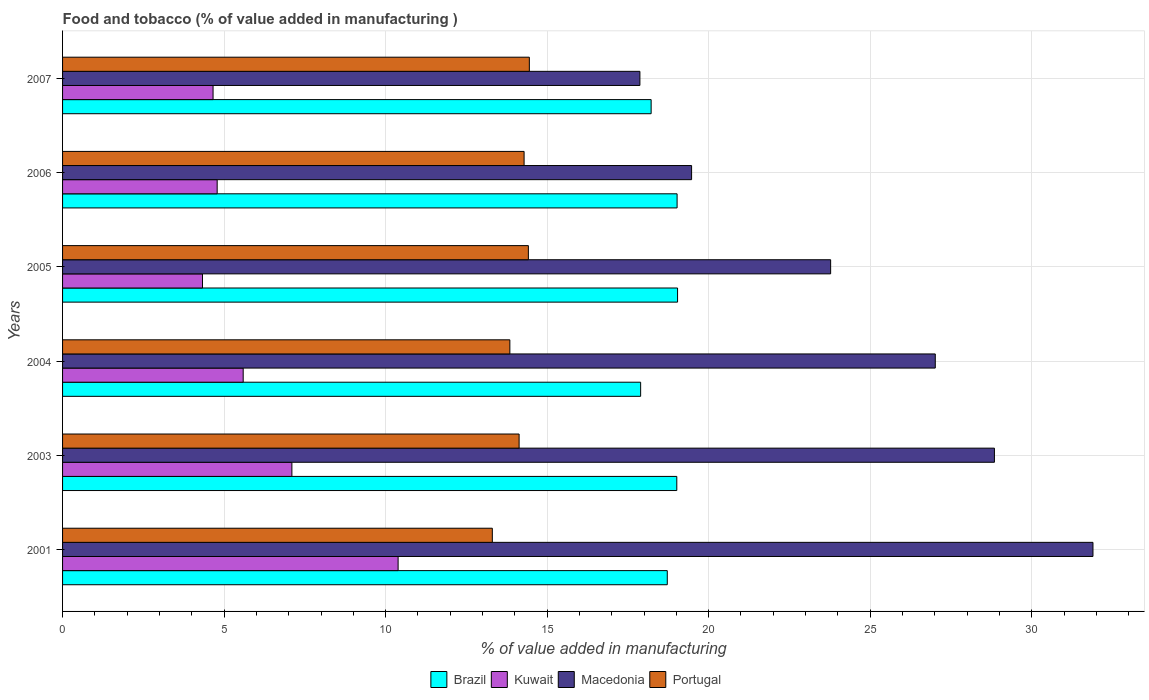Are the number of bars per tick equal to the number of legend labels?
Your answer should be very brief. Yes. What is the label of the 3rd group of bars from the top?
Give a very brief answer. 2005. In how many cases, is the number of bars for a given year not equal to the number of legend labels?
Offer a terse response. 0. What is the value added in manufacturing food and tobacco in Brazil in 2007?
Give a very brief answer. 18.22. Across all years, what is the maximum value added in manufacturing food and tobacco in Macedonia?
Make the answer very short. 31.9. Across all years, what is the minimum value added in manufacturing food and tobacco in Portugal?
Provide a short and direct response. 13.3. In which year was the value added in manufacturing food and tobacco in Brazil maximum?
Offer a terse response. 2005. In which year was the value added in manufacturing food and tobacco in Macedonia minimum?
Keep it short and to the point. 2007. What is the total value added in manufacturing food and tobacco in Kuwait in the graph?
Your answer should be compact. 36.85. What is the difference between the value added in manufacturing food and tobacco in Brazil in 2001 and that in 2007?
Your answer should be compact. 0.5. What is the difference between the value added in manufacturing food and tobacco in Brazil in 2005 and the value added in manufacturing food and tobacco in Macedonia in 2003?
Your answer should be very brief. -9.81. What is the average value added in manufacturing food and tobacco in Kuwait per year?
Provide a short and direct response. 6.14. In the year 2005, what is the difference between the value added in manufacturing food and tobacco in Portugal and value added in manufacturing food and tobacco in Brazil?
Your answer should be very brief. -4.62. What is the ratio of the value added in manufacturing food and tobacco in Kuwait in 2001 to that in 2004?
Give a very brief answer. 1.86. Is the value added in manufacturing food and tobacco in Portugal in 2001 less than that in 2003?
Offer a terse response. Yes. Is the difference between the value added in manufacturing food and tobacco in Portugal in 2001 and 2004 greater than the difference between the value added in manufacturing food and tobacco in Brazil in 2001 and 2004?
Your answer should be very brief. No. What is the difference between the highest and the second highest value added in manufacturing food and tobacco in Macedonia?
Offer a terse response. 3.05. What is the difference between the highest and the lowest value added in manufacturing food and tobacco in Portugal?
Keep it short and to the point. 1.15. In how many years, is the value added in manufacturing food and tobacco in Kuwait greater than the average value added in manufacturing food and tobacco in Kuwait taken over all years?
Your response must be concise. 2. What does the 1st bar from the bottom in 2007 represents?
Your response must be concise. Brazil. How many bars are there?
Make the answer very short. 24. Are the values on the major ticks of X-axis written in scientific E-notation?
Keep it short and to the point. No. Does the graph contain any zero values?
Your answer should be compact. No. Does the graph contain grids?
Offer a terse response. Yes. Where does the legend appear in the graph?
Make the answer very short. Bottom center. What is the title of the graph?
Your response must be concise. Food and tobacco (% of value added in manufacturing ). Does "Mozambique" appear as one of the legend labels in the graph?
Give a very brief answer. No. What is the label or title of the X-axis?
Your answer should be very brief. % of value added in manufacturing. What is the % of value added in manufacturing in Brazil in 2001?
Your response must be concise. 18.72. What is the % of value added in manufacturing in Kuwait in 2001?
Offer a terse response. 10.39. What is the % of value added in manufacturing in Macedonia in 2001?
Give a very brief answer. 31.9. What is the % of value added in manufacturing in Portugal in 2001?
Your answer should be very brief. 13.3. What is the % of value added in manufacturing of Brazil in 2003?
Ensure brevity in your answer.  19.01. What is the % of value added in manufacturing in Kuwait in 2003?
Offer a very short reply. 7.1. What is the % of value added in manufacturing of Macedonia in 2003?
Ensure brevity in your answer.  28.85. What is the % of value added in manufacturing in Portugal in 2003?
Provide a succinct answer. 14.13. What is the % of value added in manufacturing in Brazil in 2004?
Ensure brevity in your answer.  17.89. What is the % of value added in manufacturing of Kuwait in 2004?
Your response must be concise. 5.59. What is the % of value added in manufacturing in Macedonia in 2004?
Your response must be concise. 27.01. What is the % of value added in manufacturing in Portugal in 2004?
Provide a short and direct response. 13.85. What is the % of value added in manufacturing in Brazil in 2005?
Provide a succinct answer. 19.04. What is the % of value added in manufacturing in Kuwait in 2005?
Ensure brevity in your answer.  4.33. What is the % of value added in manufacturing of Macedonia in 2005?
Give a very brief answer. 23.78. What is the % of value added in manufacturing in Portugal in 2005?
Provide a short and direct response. 14.42. What is the % of value added in manufacturing of Brazil in 2006?
Offer a terse response. 19.02. What is the % of value added in manufacturing in Kuwait in 2006?
Provide a short and direct response. 4.79. What is the % of value added in manufacturing of Macedonia in 2006?
Provide a short and direct response. 19.47. What is the % of value added in manufacturing of Portugal in 2006?
Provide a short and direct response. 14.29. What is the % of value added in manufacturing in Brazil in 2007?
Offer a terse response. 18.22. What is the % of value added in manufacturing in Kuwait in 2007?
Offer a terse response. 4.66. What is the % of value added in manufacturing in Macedonia in 2007?
Make the answer very short. 17.87. What is the % of value added in manufacturing of Portugal in 2007?
Make the answer very short. 14.45. Across all years, what is the maximum % of value added in manufacturing in Brazil?
Offer a very short reply. 19.04. Across all years, what is the maximum % of value added in manufacturing of Kuwait?
Make the answer very short. 10.39. Across all years, what is the maximum % of value added in manufacturing of Macedonia?
Make the answer very short. 31.9. Across all years, what is the maximum % of value added in manufacturing in Portugal?
Your answer should be very brief. 14.45. Across all years, what is the minimum % of value added in manufacturing in Brazil?
Give a very brief answer. 17.89. Across all years, what is the minimum % of value added in manufacturing of Kuwait?
Make the answer very short. 4.33. Across all years, what is the minimum % of value added in manufacturing of Macedonia?
Offer a terse response. 17.87. Across all years, what is the minimum % of value added in manufacturing of Portugal?
Your answer should be compact. 13.3. What is the total % of value added in manufacturing in Brazil in the graph?
Offer a terse response. 111.91. What is the total % of value added in manufacturing of Kuwait in the graph?
Your answer should be compact. 36.85. What is the total % of value added in manufacturing of Macedonia in the graph?
Provide a short and direct response. 148.88. What is the total % of value added in manufacturing of Portugal in the graph?
Give a very brief answer. 84.44. What is the difference between the % of value added in manufacturing in Brazil in 2001 and that in 2003?
Make the answer very short. -0.29. What is the difference between the % of value added in manufacturing of Kuwait in 2001 and that in 2003?
Your answer should be very brief. 3.29. What is the difference between the % of value added in manufacturing in Macedonia in 2001 and that in 2003?
Make the answer very short. 3.05. What is the difference between the % of value added in manufacturing in Portugal in 2001 and that in 2003?
Ensure brevity in your answer.  -0.83. What is the difference between the % of value added in manufacturing in Brazil in 2001 and that in 2004?
Ensure brevity in your answer.  0.82. What is the difference between the % of value added in manufacturing in Kuwait in 2001 and that in 2004?
Provide a short and direct response. 4.8. What is the difference between the % of value added in manufacturing of Macedonia in 2001 and that in 2004?
Give a very brief answer. 4.88. What is the difference between the % of value added in manufacturing of Portugal in 2001 and that in 2004?
Offer a terse response. -0.54. What is the difference between the % of value added in manufacturing of Brazil in 2001 and that in 2005?
Ensure brevity in your answer.  -0.32. What is the difference between the % of value added in manufacturing of Kuwait in 2001 and that in 2005?
Offer a very short reply. 6.05. What is the difference between the % of value added in manufacturing of Macedonia in 2001 and that in 2005?
Your response must be concise. 8.12. What is the difference between the % of value added in manufacturing in Portugal in 2001 and that in 2005?
Make the answer very short. -1.12. What is the difference between the % of value added in manufacturing of Brazil in 2001 and that in 2006?
Provide a short and direct response. -0.3. What is the difference between the % of value added in manufacturing of Kuwait in 2001 and that in 2006?
Provide a succinct answer. 5.6. What is the difference between the % of value added in manufacturing of Macedonia in 2001 and that in 2006?
Ensure brevity in your answer.  12.42. What is the difference between the % of value added in manufacturing in Portugal in 2001 and that in 2006?
Give a very brief answer. -0.98. What is the difference between the % of value added in manufacturing of Brazil in 2001 and that in 2007?
Offer a terse response. 0.5. What is the difference between the % of value added in manufacturing in Kuwait in 2001 and that in 2007?
Make the answer very short. 5.73. What is the difference between the % of value added in manufacturing in Macedonia in 2001 and that in 2007?
Ensure brevity in your answer.  14.02. What is the difference between the % of value added in manufacturing of Portugal in 2001 and that in 2007?
Your answer should be very brief. -1.15. What is the difference between the % of value added in manufacturing of Brazil in 2003 and that in 2004?
Your answer should be compact. 1.12. What is the difference between the % of value added in manufacturing of Kuwait in 2003 and that in 2004?
Your answer should be compact. 1.51. What is the difference between the % of value added in manufacturing of Macedonia in 2003 and that in 2004?
Ensure brevity in your answer.  1.83. What is the difference between the % of value added in manufacturing of Portugal in 2003 and that in 2004?
Keep it short and to the point. 0.29. What is the difference between the % of value added in manufacturing of Brazil in 2003 and that in 2005?
Offer a very short reply. -0.02. What is the difference between the % of value added in manufacturing in Kuwait in 2003 and that in 2005?
Your answer should be compact. 2.77. What is the difference between the % of value added in manufacturing in Macedonia in 2003 and that in 2005?
Make the answer very short. 5.07. What is the difference between the % of value added in manufacturing in Portugal in 2003 and that in 2005?
Give a very brief answer. -0.29. What is the difference between the % of value added in manufacturing of Brazil in 2003 and that in 2006?
Offer a terse response. -0.01. What is the difference between the % of value added in manufacturing in Kuwait in 2003 and that in 2006?
Offer a terse response. 2.31. What is the difference between the % of value added in manufacturing of Macedonia in 2003 and that in 2006?
Make the answer very short. 9.37. What is the difference between the % of value added in manufacturing of Portugal in 2003 and that in 2006?
Offer a terse response. -0.15. What is the difference between the % of value added in manufacturing in Brazil in 2003 and that in 2007?
Your answer should be compact. 0.79. What is the difference between the % of value added in manufacturing of Kuwait in 2003 and that in 2007?
Offer a terse response. 2.44. What is the difference between the % of value added in manufacturing of Macedonia in 2003 and that in 2007?
Keep it short and to the point. 10.97. What is the difference between the % of value added in manufacturing of Portugal in 2003 and that in 2007?
Ensure brevity in your answer.  -0.32. What is the difference between the % of value added in manufacturing in Brazil in 2004 and that in 2005?
Keep it short and to the point. -1.14. What is the difference between the % of value added in manufacturing in Kuwait in 2004 and that in 2005?
Ensure brevity in your answer.  1.26. What is the difference between the % of value added in manufacturing in Macedonia in 2004 and that in 2005?
Offer a terse response. 3.24. What is the difference between the % of value added in manufacturing of Portugal in 2004 and that in 2005?
Give a very brief answer. -0.57. What is the difference between the % of value added in manufacturing of Brazil in 2004 and that in 2006?
Your answer should be compact. -1.13. What is the difference between the % of value added in manufacturing in Kuwait in 2004 and that in 2006?
Make the answer very short. 0.81. What is the difference between the % of value added in manufacturing of Macedonia in 2004 and that in 2006?
Provide a succinct answer. 7.54. What is the difference between the % of value added in manufacturing of Portugal in 2004 and that in 2006?
Your answer should be very brief. -0.44. What is the difference between the % of value added in manufacturing of Brazil in 2004 and that in 2007?
Provide a succinct answer. -0.33. What is the difference between the % of value added in manufacturing in Kuwait in 2004 and that in 2007?
Make the answer very short. 0.93. What is the difference between the % of value added in manufacturing of Macedonia in 2004 and that in 2007?
Provide a short and direct response. 9.14. What is the difference between the % of value added in manufacturing in Portugal in 2004 and that in 2007?
Your answer should be very brief. -0.6. What is the difference between the % of value added in manufacturing in Brazil in 2005 and that in 2006?
Offer a very short reply. 0.01. What is the difference between the % of value added in manufacturing in Kuwait in 2005 and that in 2006?
Your response must be concise. -0.45. What is the difference between the % of value added in manufacturing of Macedonia in 2005 and that in 2006?
Give a very brief answer. 4.3. What is the difference between the % of value added in manufacturing in Portugal in 2005 and that in 2006?
Your response must be concise. 0.13. What is the difference between the % of value added in manufacturing in Brazil in 2005 and that in 2007?
Your answer should be very brief. 0.82. What is the difference between the % of value added in manufacturing of Kuwait in 2005 and that in 2007?
Provide a short and direct response. -0.33. What is the difference between the % of value added in manufacturing of Macedonia in 2005 and that in 2007?
Provide a succinct answer. 5.9. What is the difference between the % of value added in manufacturing in Portugal in 2005 and that in 2007?
Your response must be concise. -0.03. What is the difference between the % of value added in manufacturing in Brazil in 2006 and that in 2007?
Your answer should be compact. 0.8. What is the difference between the % of value added in manufacturing of Kuwait in 2006 and that in 2007?
Make the answer very short. 0.13. What is the difference between the % of value added in manufacturing of Macedonia in 2006 and that in 2007?
Offer a terse response. 1.6. What is the difference between the % of value added in manufacturing in Portugal in 2006 and that in 2007?
Ensure brevity in your answer.  -0.16. What is the difference between the % of value added in manufacturing of Brazil in 2001 and the % of value added in manufacturing of Kuwait in 2003?
Provide a succinct answer. 11.62. What is the difference between the % of value added in manufacturing of Brazil in 2001 and the % of value added in manufacturing of Macedonia in 2003?
Provide a succinct answer. -10.13. What is the difference between the % of value added in manufacturing in Brazil in 2001 and the % of value added in manufacturing in Portugal in 2003?
Provide a succinct answer. 4.59. What is the difference between the % of value added in manufacturing in Kuwait in 2001 and the % of value added in manufacturing in Macedonia in 2003?
Keep it short and to the point. -18.46. What is the difference between the % of value added in manufacturing of Kuwait in 2001 and the % of value added in manufacturing of Portugal in 2003?
Make the answer very short. -3.75. What is the difference between the % of value added in manufacturing of Macedonia in 2001 and the % of value added in manufacturing of Portugal in 2003?
Your response must be concise. 17.76. What is the difference between the % of value added in manufacturing of Brazil in 2001 and the % of value added in manufacturing of Kuwait in 2004?
Ensure brevity in your answer.  13.13. What is the difference between the % of value added in manufacturing in Brazil in 2001 and the % of value added in manufacturing in Macedonia in 2004?
Your answer should be very brief. -8.3. What is the difference between the % of value added in manufacturing of Brazil in 2001 and the % of value added in manufacturing of Portugal in 2004?
Keep it short and to the point. 4.87. What is the difference between the % of value added in manufacturing of Kuwait in 2001 and the % of value added in manufacturing of Macedonia in 2004?
Your response must be concise. -16.63. What is the difference between the % of value added in manufacturing of Kuwait in 2001 and the % of value added in manufacturing of Portugal in 2004?
Provide a short and direct response. -3.46. What is the difference between the % of value added in manufacturing of Macedonia in 2001 and the % of value added in manufacturing of Portugal in 2004?
Provide a succinct answer. 18.05. What is the difference between the % of value added in manufacturing of Brazil in 2001 and the % of value added in manufacturing of Kuwait in 2005?
Offer a terse response. 14.39. What is the difference between the % of value added in manufacturing in Brazil in 2001 and the % of value added in manufacturing in Macedonia in 2005?
Provide a short and direct response. -5.06. What is the difference between the % of value added in manufacturing of Brazil in 2001 and the % of value added in manufacturing of Portugal in 2005?
Your answer should be compact. 4.3. What is the difference between the % of value added in manufacturing of Kuwait in 2001 and the % of value added in manufacturing of Macedonia in 2005?
Offer a very short reply. -13.39. What is the difference between the % of value added in manufacturing of Kuwait in 2001 and the % of value added in manufacturing of Portugal in 2005?
Your answer should be compact. -4.03. What is the difference between the % of value added in manufacturing of Macedonia in 2001 and the % of value added in manufacturing of Portugal in 2005?
Offer a terse response. 17.48. What is the difference between the % of value added in manufacturing in Brazil in 2001 and the % of value added in manufacturing in Kuwait in 2006?
Your response must be concise. 13.93. What is the difference between the % of value added in manufacturing in Brazil in 2001 and the % of value added in manufacturing in Macedonia in 2006?
Offer a terse response. -0.75. What is the difference between the % of value added in manufacturing of Brazil in 2001 and the % of value added in manufacturing of Portugal in 2006?
Provide a short and direct response. 4.43. What is the difference between the % of value added in manufacturing in Kuwait in 2001 and the % of value added in manufacturing in Macedonia in 2006?
Provide a succinct answer. -9.08. What is the difference between the % of value added in manufacturing in Kuwait in 2001 and the % of value added in manufacturing in Portugal in 2006?
Provide a short and direct response. -3.9. What is the difference between the % of value added in manufacturing of Macedonia in 2001 and the % of value added in manufacturing of Portugal in 2006?
Your answer should be compact. 17.61. What is the difference between the % of value added in manufacturing of Brazil in 2001 and the % of value added in manufacturing of Kuwait in 2007?
Your answer should be very brief. 14.06. What is the difference between the % of value added in manufacturing in Brazil in 2001 and the % of value added in manufacturing in Macedonia in 2007?
Offer a very short reply. 0.85. What is the difference between the % of value added in manufacturing in Brazil in 2001 and the % of value added in manufacturing in Portugal in 2007?
Provide a succinct answer. 4.27. What is the difference between the % of value added in manufacturing in Kuwait in 2001 and the % of value added in manufacturing in Macedonia in 2007?
Your response must be concise. -7.48. What is the difference between the % of value added in manufacturing of Kuwait in 2001 and the % of value added in manufacturing of Portugal in 2007?
Your response must be concise. -4.06. What is the difference between the % of value added in manufacturing in Macedonia in 2001 and the % of value added in manufacturing in Portugal in 2007?
Your answer should be compact. 17.45. What is the difference between the % of value added in manufacturing in Brazil in 2003 and the % of value added in manufacturing in Kuwait in 2004?
Ensure brevity in your answer.  13.42. What is the difference between the % of value added in manufacturing of Brazil in 2003 and the % of value added in manufacturing of Macedonia in 2004?
Offer a very short reply. -8. What is the difference between the % of value added in manufacturing in Brazil in 2003 and the % of value added in manufacturing in Portugal in 2004?
Give a very brief answer. 5.17. What is the difference between the % of value added in manufacturing of Kuwait in 2003 and the % of value added in manufacturing of Macedonia in 2004?
Make the answer very short. -19.92. What is the difference between the % of value added in manufacturing of Kuwait in 2003 and the % of value added in manufacturing of Portugal in 2004?
Provide a succinct answer. -6.75. What is the difference between the % of value added in manufacturing in Macedonia in 2003 and the % of value added in manufacturing in Portugal in 2004?
Your answer should be compact. 15. What is the difference between the % of value added in manufacturing of Brazil in 2003 and the % of value added in manufacturing of Kuwait in 2005?
Make the answer very short. 14.68. What is the difference between the % of value added in manufacturing of Brazil in 2003 and the % of value added in manufacturing of Macedonia in 2005?
Your answer should be very brief. -4.76. What is the difference between the % of value added in manufacturing of Brazil in 2003 and the % of value added in manufacturing of Portugal in 2005?
Your response must be concise. 4.59. What is the difference between the % of value added in manufacturing of Kuwait in 2003 and the % of value added in manufacturing of Macedonia in 2005?
Your answer should be compact. -16.68. What is the difference between the % of value added in manufacturing in Kuwait in 2003 and the % of value added in manufacturing in Portugal in 2005?
Make the answer very short. -7.32. What is the difference between the % of value added in manufacturing in Macedonia in 2003 and the % of value added in manufacturing in Portugal in 2005?
Provide a succinct answer. 14.43. What is the difference between the % of value added in manufacturing of Brazil in 2003 and the % of value added in manufacturing of Kuwait in 2006?
Your answer should be very brief. 14.23. What is the difference between the % of value added in manufacturing of Brazil in 2003 and the % of value added in manufacturing of Macedonia in 2006?
Give a very brief answer. -0.46. What is the difference between the % of value added in manufacturing in Brazil in 2003 and the % of value added in manufacturing in Portugal in 2006?
Offer a very short reply. 4.73. What is the difference between the % of value added in manufacturing in Kuwait in 2003 and the % of value added in manufacturing in Macedonia in 2006?
Offer a terse response. -12.37. What is the difference between the % of value added in manufacturing in Kuwait in 2003 and the % of value added in manufacturing in Portugal in 2006?
Provide a short and direct response. -7.19. What is the difference between the % of value added in manufacturing of Macedonia in 2003 and the % of value added in manufacturing of Portugal in 2006?
Give a very brief answer. 14.56. What is the difference between the % of value added in manufacturing of Brazil in 2003 and the % of value added in manufacturing of Kuwait in 2007?
Your answer should be compact. 14.35. What is the difference between the % of value added in manufacturing in Brazil in 2003 and the % of value added in manufacturing in Macedonia in 2007?
Keep it short and to the point. 1.14. What is the difference between the % of value added in manufacturing in Brazil in 2003 and the % of value added in manufacturing in Portugal in 2007?
Offer a terse response. 4.56. What is the difference between the % of value added in manufacturing in Kuwait in 2003 and the % of value added in manufacturing in Macedonia in 2007?
Your answer should be compact. -10.77. What is the difference between the % of value added in manufacturing of Kuwait in 2003 and the % of value added in manufacturing of Portugal in 2007?
Make the answer very short. -7.35. What is the difference between the % of value added in manufacturing in Macedonia in 2003 and the % of value added in manufacturing in Portugal in 2007?
Your answer should be very brief. 14.4. What is the difference between the % of value added in manufacturing in Brazil in 2004 and the % of value added in manufacturing in Kuwait in 2005?
Make the answer very short. 13.56. What is the difference between the % of value added in manufacturing of Brazil in 2004 and the % of value added in manufacturing of Macedonia in 2005?
Make the answer very short. -5.88. What is the difference between the % of value added in manufacturing in Brazil in 2004 and the % of value added in manufacturing in Portugal in 2005?
Provide a short and direct response. 3.48. What is the difference between the % of value added in manufacturing in Kuwait in 2004 and the % of value added in manufacturing in Macedonia in 2005?
Give a very brief answer. -18.18. What is the difference between the % of value added in manufacturing in Kuwait in 2004 and the % of value added in manufacturing in Portugal in 2005?
Provide a succinct answer. -8.83. What is the difference between the % of value added in manufacturing in Macedonia in 2004 and the % of value added in manufacturing in Portugal in 2005?
Provide a short and direct response. 12.6. What is the difference between the % of value added in manufacturing of Brazil in 2004 and the % of value added in manufacturing of Kuwait in 2006?
Provide a succinct answer. 13.11. What is the difference between the % of value added in manufacturing in Brazil in 2004 and the % of value added in manufacturing in Macedonia in 2006?
Make the answer very short. -1.58. What is the difference between the % of value added in manufacturing of Brazil in 2004 and the % of value added in manufacturing of Portugal in 2006?
Offer a very short reply. 3.61. What is the difference between the % of value added in manufacturing of Kuwait in 2004 and the % of value added in manufacturing of Macedonia in 2006?
Make the answer very short. -13.88. What is the difference between the % of value added in manufacturing in Kuwait in 2004 and the % of value added in manufacturing in Portugal in 2006?
Offer a terse response. -8.7. What is the difference between the % of value added in manufacturing of Macedonia in 2004 and the % of value added in manufacturing of Portugal in 2006?
Your response must be concise. 12.73. What is the difference between the % of value added in manufacturing of Brazil in 2004 and the % of value added in manufacturing of Kuwait in 2007?
Keep it short and to the point. 13.24. What is the difference between the % of value added in manufacturing in Brazil in 2004 and the % of value added in manufacturing in Macedonia in 2007?
Offer a very short reply. 0.02. What is the difference between the % of value added in manufacturing of Brazil in 2004 and the % of value added in manufacturing of Portugal in 2007?
Your answer should be very brief. 3.45. What is the difference between the % of value added in manufacturing of Kuwait in 2004 and the % of value added in manufacturing of Macedonia in 2007?
Your answer should be compact. -12.28. What is the difference between the % of value added in manufacturing of Kuwait in 2004 and the % of value added in manufacturing of Portugal in 2007?
Give a very brief answer. -8.86. What is the difference between the % of value added in manufacturing in Macedonia in 2004 and the % of value added in manufacturing in Portugal in 2007?
Your answer should be compact. 12.57. What is the difference between the % of value added in manufacturing of Brazil in 2005 and the % of value added in manufacturing of Kuwait in 2006?
Give a very brief answer. 14.25. What is the difference between the % of value added in manufacturing of Brazil in 2005 and the % of value added in manufacturing of Macedonia in 2006?
Provide a succinct answer. -0.43. What is the difference between the % of value added in manufacturing of Brazil in 2005 and the % of value added in manufacturing of Portugal in 2006?
Make the answer very short. 4.75. What is the difference between the % of value added in manufacturing in Kuwait in 2005 and the % of value added in manufacturing in Macedonia in 2006?
Your response must be concise. -15.14. What is the difference between the % of value added in manufacturing in Kuwait in 2005 and the % of value added in manufacturing in Portugal in 2006?
Offer a very short reply. -9.95. What is the difference between the % of value added in manufacturing in Macedonia in 2005 and the % of value added in manufacturing in Portugal in 2006?
Give a very brief answer. 9.49. What is the difference between the % of value added in manufacturing in Brazil in 2005 and the % of value added in manufacturing in Kuwait in 2007?
Your response must be concise. 14.38. What is the difference between the % of value added in manufacturing of Brazil in 2005 and the % of value added in manufacturing of Macedonia in 2007?
Provide a short and direct response. 1.17. What is the difference between the % of value added in manufacturing of Brazil in 2005 and the % of value added in manufacturing of Portugal in 2007?
Offer a terse response. 4.59. What is the difference between the % of value added in manufacturing of Kuwait in 2005 and the % of value added in manufacturing of Macedonia in 2007?
Offer a very short reply. -13.54. What is the difference between the % of value added in manufacturing of Kuwait in 2005 and the % of value added in manufacturing of Portugal in 2007?
Your answer should be compact. -10.12. What is the difference between the % of value added in manufacturing of Macedonia in 2005 and the % of value added in manufacturing of Portugal in 2007?
Give a very brief answer. 9.33. What is the difference between the % of value added in manufacturing in Brazil in 2006 and the % of value added in manufacturing in Kuwait in 2007?
Provide a short and direct response. 14.36. What is the difference between the % of value added in manufacturing of Brazil in 2006 and the % of value added in manufacturing of Macedonia in 2007?
Your answer should be compact. 1.15. What is the difference between the % of value added in manufacturing of Brazil in 2006 and the % of value added in manufacturing of Portugal in 2007?
Your answer should be compact. 4.57. What is the difference between the % of value added in manufacturing of Kuwait in 2006 and the % of value added in manufacturing of Macedonia in 2007?
Provide a short and direct response. -13.09. What is the difference between the % of value added in manufacturing of Kuwait in 2006 and the % of value added in manufacturing of Portugal in 2007?
Keep it short and to the point. -9.66. What is the difference between the % of value added in manufacturing of Macedonia in 2006 and the % of value added in manufacturing of Portugal in 2007?
Your response must be concise. 5.02. What is the average % of value added in manufacturing in Brazil per year?
Ensure brevity in your answer.  18.65. What is the average % of value added in manufacturing in Kuwait per year?
Offer a very short reply. 6.14. What is the average % of value added in manufacturing in Macedonia per year?
Make the answer very short. 24.81. What is the average % of value added in manufacturing of Portugal per year?
Provide a succinct answer. 14.07. In the year 2001, what is the difference between the % of value added in manufacturing in Brazil and % of value added in manufacturing in Kuwait?
Offer a very short reply. 8.33. In the year 2001, what is the difference between the % of value added in manufacturing in Brazil and % of value added in manufacturing in Macedonia?
Your response must be concise. -13.18. In the year 2001, what is the difference between the % of value added in manufacturing in Brazil and % of value added in manufacturing in Portugal?
Ensure brevity in your answer.  5.42. In the year 2001, what is the difference between the % of value added in manufacturing of Kuwait and % of value added in manufacturing of Macedonia?
Offer a terse response. -21.51. In the year 2001, what is the difference between the % of value added in manufacturing in Kuwait and % of value added in manufacturing in Portugal?
Offer a terse response. -2.92. In the year 2001, what is the difference between the % of value added in manufacturing of Macedonia and % of value added in manufacturing of Portugal?
Offer a terse response. 18.59. In the year 2003, what is the difference between the % of value added in manufacturing of Brazil and % of value added in manufacturing of Kuwait?
Offer a very short reply. 11.91. In the year 2003, what is the difference between the % of value added in manufacturing of Brazil and % of value added in manufacturing of Macedonia?
Provide a short and direct response. -9.83. In the year 2003, what is the difference between the % of value added in manufacturing in Brazil and % of value added in manufacturing in Portugal?
Provide a succinct answer. 4.88. In the year 2003, what is the difference between the % of value added in manufacturing of Kuwait and % of value added in manufacturing of Macedonia?
Your response must be concise. -21.75. In the year 2003, what is the difference between the % of value added in manufacturing in Kuwait and % of value added in manufacturing in Portugal?
Offer a terse response. -7.03. In the year 2003, what is the difference between the % of value added in manufacturing in Macedonia and % of value added in manufacturing in Portugal?
Your answer should be very brief. 14.71. In the year 2004, what is the difference between the % of value added in manufacturing in Brazil and % of value added in manufacturing in Kuwait?
Make the answer very short. 12.3. In the year 2004, what is the difference between the % of value added in manufacturing of Brazil and % of value added in manufacturing of Macedonia?
Give a very brief answer. -9.12. In the year 2004, what is the difference between the % of value added in manufacturing in Brazil and % of value added in manufacturing in Portugal?
Your answer should be very brief. 4.05. In the year 2004, what is the difference between the % of value added in manufacturing of Kuwait and % of value added in manufacturing of Macedonia?
Provide a short and direct response. -21.42. In the year 2004, what is the difference between the % of value added in manufacturing in Kuwait and % of value added in manufacturing in Portugal?
Offer a very short reply. -8.25. In the year 2004, what is the difference between the % of value added in manufacturing of Macedonia and % of value added in manufacturing of Portugal?
Offer a terse response. 13.17. In the year 2005, what is the difference between the % of value added in manufacturing of Brazil and % of value added in manufacturing of Kuwait?
Your answer should be very brief. 14.71. In the year 2005, what is the difference between the % of value added in manufacturing of Brazil and % of value added in manufacturing of Macedonia?
Your answer should be compact. -4.74. In the year 2005, what is the difference between the % of value added in manufacturing in Brazil and % of value added in manufacturing in Portugal?
Offer a terse response. 4.62. In the year 2005, what is the difference between the % of value added in manufacturing of Kuwait and % of value added in manufacturing of Macedonia?
Your answer should be very brief. -19.44. In the year 2005, what is the difference between the % of value added in manufacturing in Kuwait and % of value added in manufacturing in Portugal?
Your answer should be compact. -10.09. In the year 2005, what is the difference between the % of value added in manufacturing in Macedonia and % of value added in manufacturing in Portugal?
Offer a terse response. 9.36. In the year 2006, what is the difference between the % of value added in manufacturing of Brazil and % of value added in manufacturing of Kuwait?
Offer a terse response. 14.24. In the year 2006, what is the difference between the % of value added in manufacturing of Brazil and % of value added in manufacturing of Macedonia?
Provide a short and direct response. -0.45. In the year 2006, what is the difference between the % of value added in manufacturing of Brazil and % of value added in manufacturing of Portugal?
Offer a terse response. 4.74. In the year 2006, what is the difference between the % of value added in manufacturing of Kuwait and % of value added in manufacturing of Macedonia?
Your answer should be compact. -14.69. In the year 2006, what is the difference between the % of value added in manufacturing in Kuwait and % of value added in manufacturing in Portugal?
Offer a terse response. -9.5. In the year 2006, what is the difference between the % of value added in manufacturing of Macedonia and % of value added in manufacturing of Portugal?
Your answer should be very brief. 5.18. In the year 2007, what is the difference between the % of value added in manufacturing in Brazil and % of value added in manufacturing in Kuwait?
Offer a terse response. 13.56. In the year 2007, what is the difference between the % of value added in manufacturing in Brazil and % of value added in manufacturing in Macedonia?
Provide a short and direct response. 0.35. In the year 2007, what is the difference between the % of value added in manufacturing of Brazil and % of value added in manufacturing of Portugal?
Offer a very short reply. 3.77. In the year 2007, what is the difference between the % of value added in manufacturing of Kuwait and % of value added in manufacturing of Macedonia?
Ensure brevity in your answer.  -13.21. In the year 2007, what is the difference between the % of value added in manufacturing in Kuwait and % of value added in manufacturing in Portugal?
Give a very brief answer. -9.79. In the year 2007, what is the difference between the % of value added in manufacturing in Macedonia and % of value added in manufacturing in Portugal?
Your response must be concise. 3.42. What is the ratio of the % of value added in manufacturing of Brazil in 2001 to that in 2003?
Give a very brief answer. 0.98. What is the ratio of the % of value added in manufacturing in Kuwait in 2001 to that in 2003?
Provide a short and direct response. 1.46. What is the ratio of the % of value added in manufacturing in Macedonia in 2001 to that in 2003?
Offer a terse response. 1.11. What is the ratio of the % of value added in manufacturing in Portugal in 2001 to that in 2003?
Offer a very short reply. 0.94. What is the ratio of the % of value added in manufacturing in Brazil in 2001 to that in 2004?
Give a very brief answer. 1.05. What is the ratio of the % of value added in manufacturing of Kuwait in 2001 to that in 2004?
Your answer should be compact. 1.86. What is the ratio of the % of value added in manufacturing in Macedonia in 2001 to that in 2004?
Give a very brief answer. 1.18. What is the ratio of the % of value added in manufacturing in Portugal in 2001 to that in 2004?
Make the answer very short. 0.96. What is the ratio of the % of value added in manufacturing in Brazil in 2001 to that in 2005?
Offer a terse response. 0.98. What is the ratio of the % of value added in manufacturing in Kuwait in 2001 to that in 2005?
Make the answer very short. 2.4. What is the ratio of the % of value added in manufacturing in Macedonia in 2001 to that in 2005?
Give a very brief answer. 1.34. What is the ratio of the % of value added in manufacturing in Portugal in 2001 to that in 2005?
Your response must be concise. 0.92. What is the ratio of the % of value added in manufacturing of Kuwait in 2001 to that in 2006?
Offer a terse response. 2.17. What is the ratio of the % of value added in manufacturing of Macedonia in 2001 to that in 2006?
Provide a succinct answer. 1.64. What is the ratio of the % of value added in manufacturing in Portugal in 2001 to that in 2006?
Keep it short and to the point. 0.93. What is the ratio of the % of value added in manufacturing in Brazil in 2001 to that in 2007?
Provide a succinct answer. 1.03. What is the ratio of the % of value added in manufacturing in Kuwait in 2001 to that in 2007?
Offer a terse response. 2.23. What is the ratio of the % of value added in manufacturing of Macedonia in 2001 to that in 2007?
Your response must be concise. 1.78. What is the ratio of the % of value added in manufacturing of Portugal in 2001 to that in 2007?
Make the answer very short. 0.92. What is the ratio of the % of value added in manufacturing in Brazil in 2003 to that in 2004?
Your answer should be compact. 1.06. What is the ratio of the % of value added in manufacturing of Kuwait in 2003 to that in 2004?
Offer a very short reply. 1.27. What is the ratio of the % of value added in manufacturing of Macedonia in 2003 to that in 2004?
Provide a short and direct response. 1.07. What is the ratio of the % of value added in manufacturing of Portugal in 2003 to that in 2004?
Offer a very short reply. 1.02. What is the ratio of the % of value added in manufacturing of Brazil in 2003 to that in 2005?
Provide a short and direct response. 1. What is the ratio of the % of value added in manufacturing in Kuwait in 2003 to that in 2005?
Provide a short and direct response. 1.64. What is the ratio of the % of value added in manufacturing in Macedonia in 2003 to that in 2005?
Offer a terse response. 1.21. What is the ratio of the % of value added in manufacturing of Portugal in 2003 to that in 2005?
Give a very brief answer. 0.98. What is the ratio of the % of value added in manufacturing in Brazil in 2003 to that in 2006?
Your response must be concise. 1. What is the ratio of the % of value added in manufacturing in Kuwait in 2003 to that in 2006?
Offer a terse response. 1.48. What is the ratio of the % of value added in manufacturing in Macedonia in 2003 to that in 2006?
Offer a very short reply. 1.48. What is the ratio of the % of value added in manufacturing in Portugal in 2003 to that in 2006?
Provide a succinct answer. 0.99. What is the ratio of the % of value added in manufacturing in Brazil in 2003 to that in 2007?
Provide a short and direct response. 1.04. What is the ratio of the % of value added in manufacturing of Kuwait in 2003 to that in 2007?
Your answer should be compact. 1.52. What is the ratio of the % of value added in manufacturing in Macedonia in 2003 to that in 2007?
Your response must be concise. 1.61. What is the ratio of the % of value added in manufacturing of Portugal in 2003 to that in 2007?
Provide a short and direct response. 0.98. What is the ratio of the % of value added in manufacturing in Brazil in 2004 to that in 2005?
Offer a terse response. 0.94. What is the ratio of the % of value added in manufacturing of Kuwait in 2004 to that in 2005?
Offer a terse response. 1.29. What is the ratio of the % of value added in manufacturing in Macedonia in 2004 to that in 2005?
Offer a very short reply. 1.14. What is the ratio of the % of value added in manufacturing of Portugal in 2004 to that in 2005?
Make the answer very short. 0.96. What is the ratio of the % of value added in manufacturing in Brazil in 2004 to that in 2006?
Provide a short and direct response. 0.94. What is the ratio of the % of value added in manufacturing of Kuwait in 2004 to that in 2006?
Offer a terse response. 1.17. What is the ratio of the % of value added in manufacturing in Macedonia in 2004 to that in 2006?
Your answer should be very brief. 1.39. What is the ratio of the % of value added in manufacturing of Portugal in 2004 to that in 2006?
Your response must be concise. 0.97. What is the ratio of the % of value added in manufacturing of Brazil in 2004 to that in 2007?
Provide a short and direct response. 0.98. What is the ratio of the % of value added in manufacturing of Kuwait in 2004 to that in 2007?
Your answer should be compact. 1.2. What is the ratio of the % of value added in manufacturing of Macedonia in 2004 to that in 2007?
Provide a short and direct response. 1.51. What is the ratio of the % of value added in manufacturing in Brazil in 2005 to that in 2006?
Keep it short and to the point. 1. What is the ratio of the % of value added in manufacturing in Kuwait in 2005 to that in 2006?
Keep it short and to the point. 0.91. What is the ratio of the % of value added in manufacturing of Macedonia in 2005 to that in 2006?
Offer a very short reply. 1.22. What is the ratio of the % of value added in manufacturing of Portugal in 2005 to that in 2006?
Your response must be concise. 1.01. What is the ratio of the % of value added in manufacturing in Brazil in 2005 to that in 2007?
Ensure brevity in your answer.  1.04. What is the ratio of the % of value added in manufacturing in Kuwait in 2005 to that in 2007?
Offer a terse response. 0.93. What is the ratio of the % of value added in manufacturing in Macedonia in 2005 to that in 2007?
Ensure brevity in your answer.  1.33. What is the ratio of the % of value added in manufacturing in Portugal in 2005 to that in 2007?
Keep it short and to the point. 1. What is the ratio of the % of value added in manufacturing of Brazil in 2006 to that in 2007?
Offer a very short reply. 1.04. What is the ratio of the % of value added in manufacturing in Kuwait in 2006 to that in 2007?
Offer a very short reply. 1.03. What is the ratio of the % of value added in manufacturing of Macedonia in 2006 to that in 2007?
Your response must be concise. 1.09. What is the ratio of the % of value added in manufacturing of Portugal in 2006 to that in 2007?
Your response must be concise. 0.99. What is the difference between the highest and the second highest % of value added in manufacturing of Brazil?
Give a very brief answer. 0.01. What is the difference between the highest and the second highest % of value added in manufacturing in Kuwait?
Offer a terse response. 3.29. What is the difference between the highest and the second highest % of value added in manufacturing in Macedonia?
Keep it short and to the point. 3.05. What is the difference between the highest and the second highest % of value added in manufacturing of Portugal?
Your answer should be compact. 0.03. What is the difference between the highest and the lowest % of value added in manufacturing of Brazil?
Provide a short and direct response. 1.14. What is the difference between the highest and the lowest % of value added in manufacturing of Kuwait?
Offer a terse response. 6.05. What is the difference between the highest and the lowest % of value added in manufacturing of Macedonia?
Your answer should be compact. 14.02. What is the difference between the highest and the lowest % of value added in manufacturing in Portugal?
Ensure brevity in your answer.  1.15. 